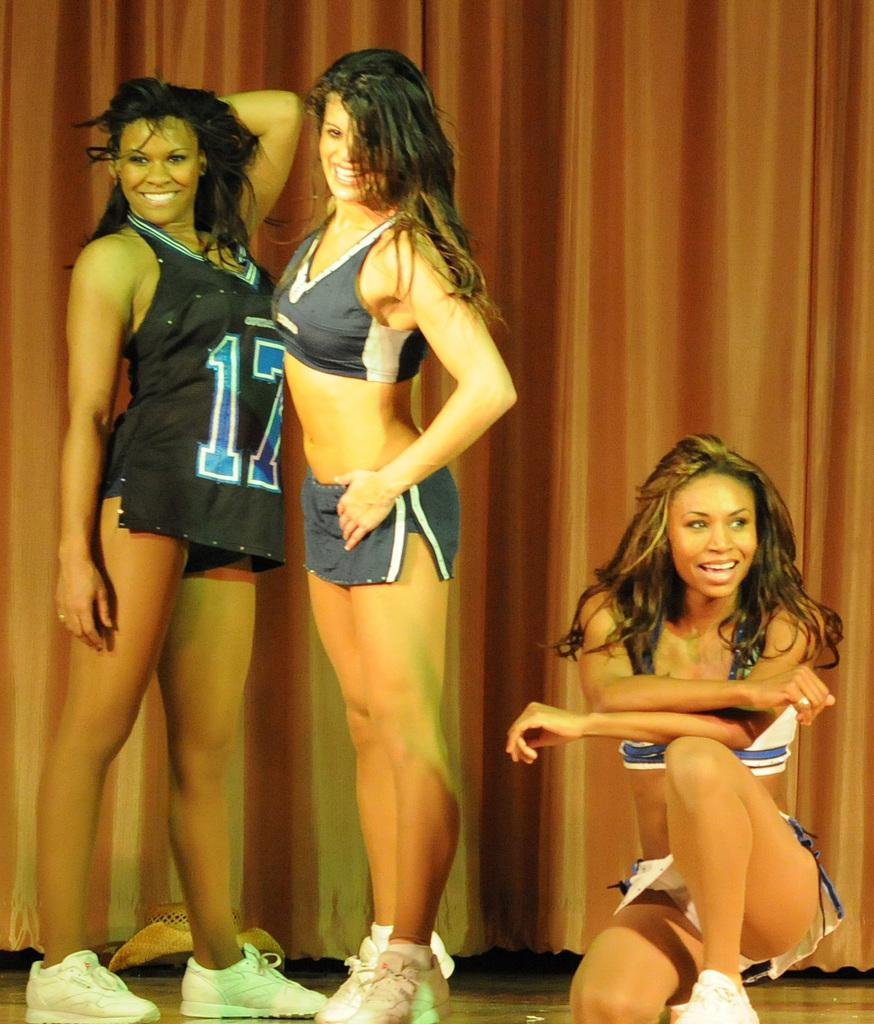<image>
Offer a succinct explanation of the picture presented. three women standing on a stage in front of a curtain, one is wearing a number 17 jersey 